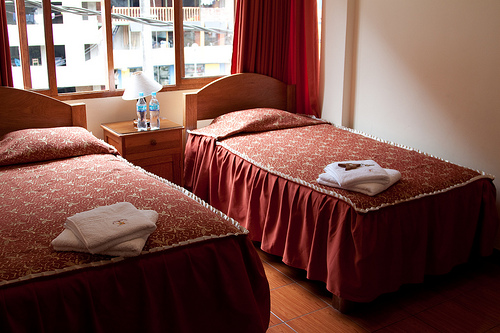Please provide a short description for this region: [0.1, 0.25, 0.15, 0.31]. The windows in this region offer a view of residential buildings opposite, characterized by balconies and multiple windows, reflecting an urban environment. 